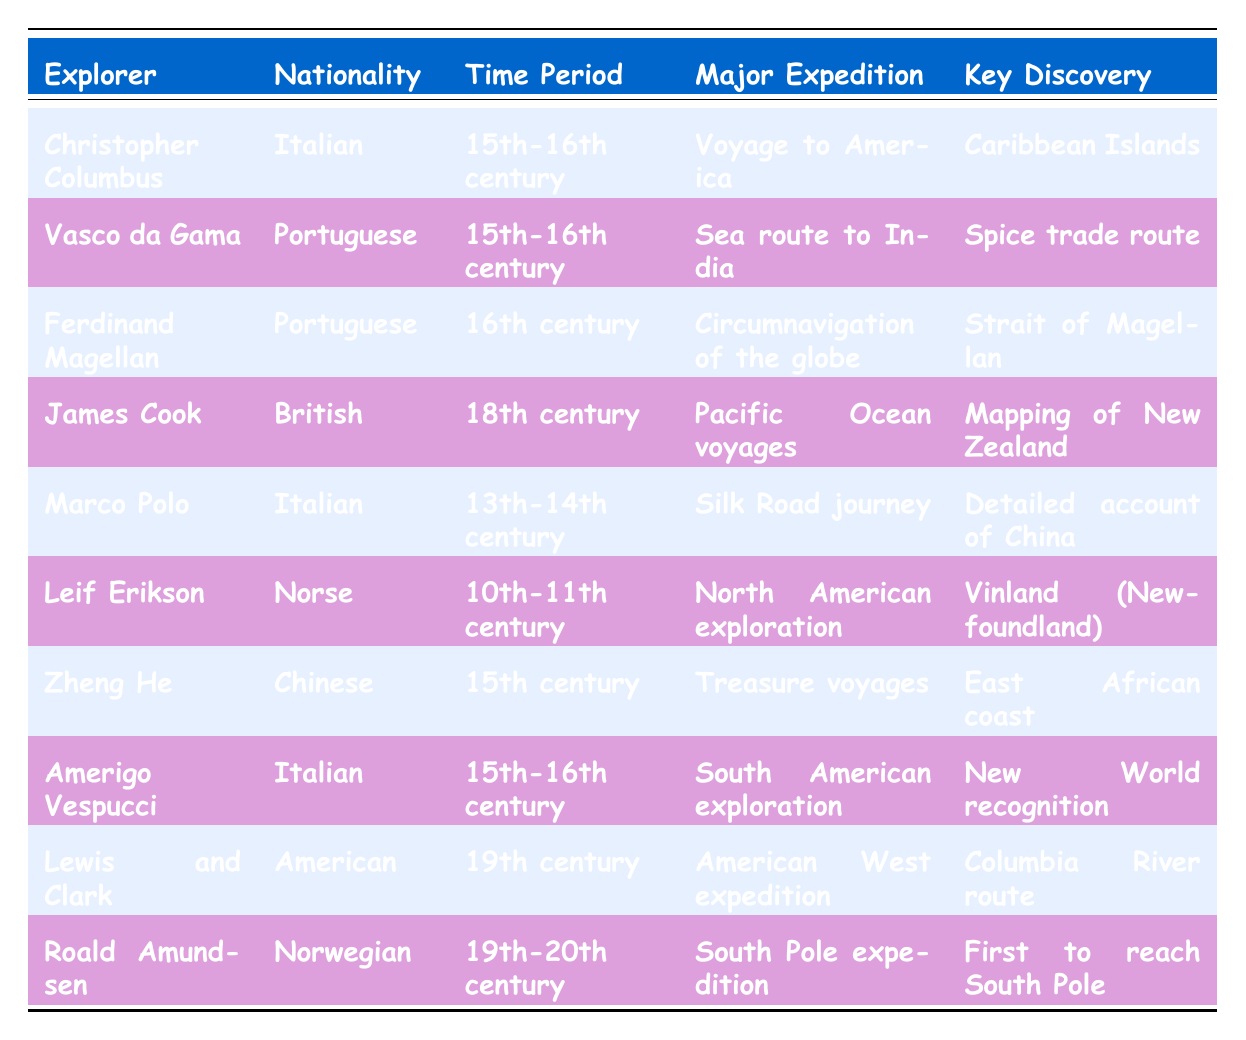What were the nationalities of explorers in the 15th-16th century? From the table, we can see that the explorers from this time period include Christopher Columbus (Italian), Vasco da Gama (Portuguese), Amerigo Vespucci (Italian), and Zheng He (Chinese). Listing these nationalities gives us Italian, Portuguese, and Chinese.
Answer: Italian, Portuguese, Chinese Who was the first explorer to reach the South Pole? According to the table, Roald Amundsen is identified as the explorer who reached the South Pole first.
Answer: Roald Amundsen How many explorers are from Italy? By reviewing the table, we find that there are four explorers identified as Italian: Christopher Columbus, Marco Polo, and Amerigo Vespucci. Hence, the total count is three.
Answer: 3 Did Zheng He discover the Silk Road? In the table, Zheng He is associated with treasure voyages and the East African coast, not with the Silk Road, which is linked to Marco Polo. Therefore, the statement is false.
Answer: No Which explorer had the major expedition focused on the spice trade route? The table indicates that Vasco da Gama's major expedition was the sea route to India, which involved the spice trade route.
Answer: Vasco da Gama What is the average time period of expeditions for the explorers listed? The time periods mentioned are 10th-11th century, 13th-14th century, 15th century, and 15th-16th century, along with 16th century, 18th century, and 19th century. Converting these century ranges to a numerical average gives us 11, 14, 15, 15.5, 16, 18, and 19. If we calculate the average (11 + 14 + 15 + 15.5 + 16 + 18 + 19) / 7, we find it equals approximately 15.07, which corresponds to roughly the 15th century.
Answer: 15th century Which explorer is associated with the mapping of New Zealand? The table states that James Cook was known for his Pacific Ocean voyages, particularly for the mapping of New Zealand.
Answer: James Cook How many explorers were from Portugal? From the table, we note that Vasco da Gama and Ferdinand Magellan are both Portuguese explorers. This shows that there are two Portuguese explorers listed.
Answer: 2 